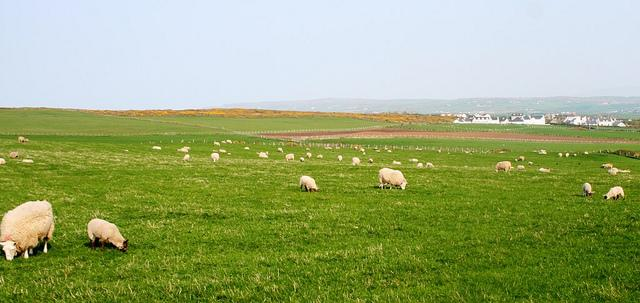What do these animals have? wool 